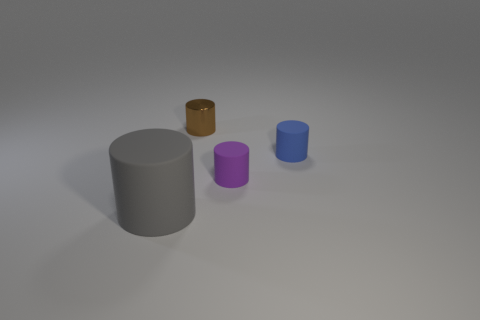What is the shape of the tiny rubber object in front of the thing that is on the right side of the purple matte object?
Make the answer very short. Cylinder. There is a gray rubber cylinder; are there any brown cylinders to the right of it?
Your answer should be compact. Yes. Is there a cylinder that is right of the rubber thing left of the tiny purple matte thing?
Your answer should be very brief. Yes. There is a matte thing on the right side of the purple object; is its size the same as the cylinder that is behind the blue rubber object?
Provide a short and direct response. Yes. What number of tiny objects are either gray matte cylinders or purple matte cylinders?
Provide a succinct answer. 1. There is a tiny object that is to the left of the small purple rubber object that is on the left side of the small blue object; what is it made of?
Offer a very short reply. Metal. Are there any large gray things that have the same material as the brown cylinder?
Make the answer very short. No. Does the purple thing have the same material as the small cylinder to the left of the purple rubber cylinder?
Offer a terse response. No. The matte thing that is the same size as the purple cylinder is what color?
Provide a short and direct response. Blue. What is the size of the rubber object behind the small cylinder that is in front of the tiny blue thing?
Ensure brevity in your answer.  Small. 